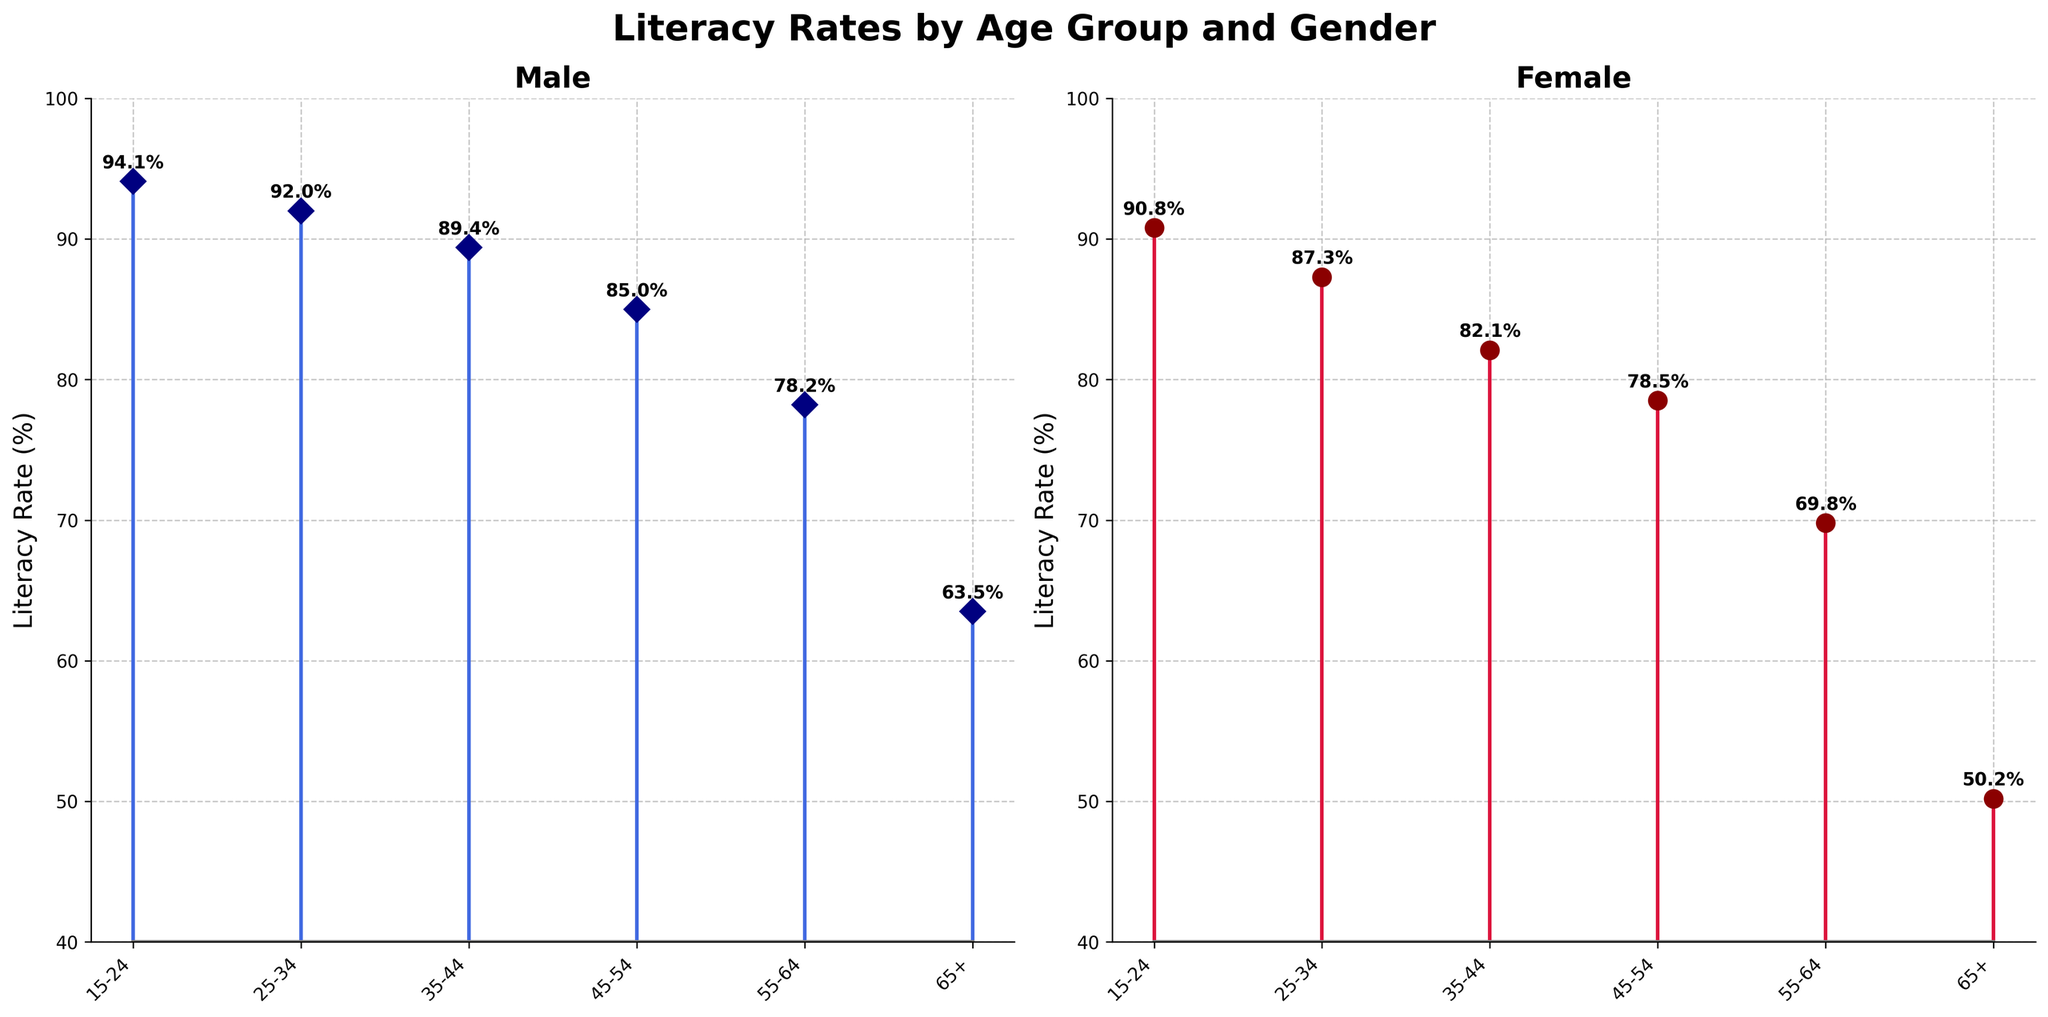What is the overall title of the figure? The overall title is located at the top center of the figure and is written in bold, large font. It summarizes the data presented in the figure.
Answer: Literacy Rates by Age Group and Gender What age group has the highest literacy rate among males? To find the highest literacy rate among males, look at the peak point in the male stem plot on the left subplot. The data point for males at 15-24 age group has the highest literacy rate.
Answer: 15-24 Which gender has lower literacy rates overall? Compare the vertical positions of the markers in both subplots (male on the left and female on the right). The female subplot has markers that are consistently lower than those in the male subplot.
Answer: Female What is the literacy rate for females in the 35-44 age group? Locate the 35-44 age group on the x-axis of the female subplot (right). Then look at the height of the corresponding marker for this age group. The annotated text above this marker shows the value.
Answer: 82.1% How does the literacy rate change from the 45-54 age group to the 55-64 age group for males? Find the markers for the 45-54 and 55-64 age groups on the male subplot (left). Note their positions and the annotated text values, then calculate the difference between them. 85.0% (45-54) decreases to 78.2% (55-64).
Answer: It decreases by 6.8% What is the difference in literacy rates between males and females in the 25-34 age group? Identify the markers for the 25-34 age group on both subplots. For males, the rate is 92.0% and for females, it is 87.3%. Subtract the female rate from the male rate. 92.0% - 87.3%.
Answer: 4.7% Which age group shows the most significant drop in literacy rate for females between consecutive age groups? Examine the female subplot to see where there is the largest vertical drop between any two consecutive age groups. The most significant drop is between 55-64 and 65+ age groups. From 69.8% (55-64) to 50.2% (65+).
Answer: 55-64 to 65+ What is the average literacy rate for males across all age groups? Sum up all the male literacy rates and divide by the number of age groups. (94.1 + 92.0 + 89.4 + 85.0 + 78.2 + 63.5) / 6
Answer: 83.7% Which age group has the smallest gender gap in literacy rate? For each age group, subtract the female literacy rate from the male literacy rate, find the minimum difference. 15-24: 94.1-90.8=3.3, 25-34: 92.0-87.3=4.7, 35-44: 89.4-82.1=7.3, 45-54: 85.0-78.5=6.5, 55-64: 78.2-69.8=8.4, 65+: 63.5-50.2=13.3. The smallest gap is 3.3% in 15-24 age group.
Answer: 15-24 